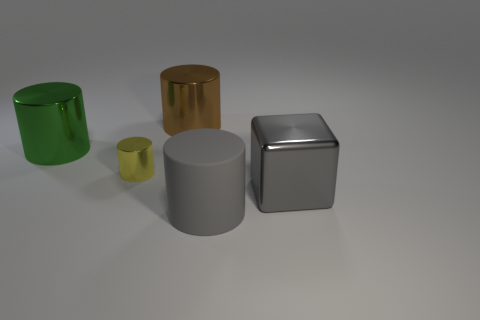There is a gray metal thing that is the same size as the brown metallic object; what is its shape?
Offer a very short reply. Cube. Do the object in front of the large gray block and the metallic object that is on the right side of the large brown thing have the same size?
Provide a short and direct response. Yes. How many objects are there?
Ensure brevity in your answer.  5. What size is the gray thing on the left side of the large gray thing that is to the right of the big cylinder that is in front of the big gray cube?
Keep it short and to the point. Large. Do the small metal thing and the big block have the same color?
Provide a succinct answer. No. Is there anything else that is the same size as the yellow metallic thing?
Your answer should be very brief. No. There is a yellow metallic cylinder; what number of big brown cylinders are right of it?
Your answer should be very brief. 1. Are there the same number of tiny yellow shiny cylinders right of the yellow object and big gray cylinders?
Offer a very short reply. No. What number of objects are large metal things or tiny green objects?
Your response must be concise. 3. Is there any other thing that is the same shape as the small yellow metal object?
Offer a terse response. Yes. 